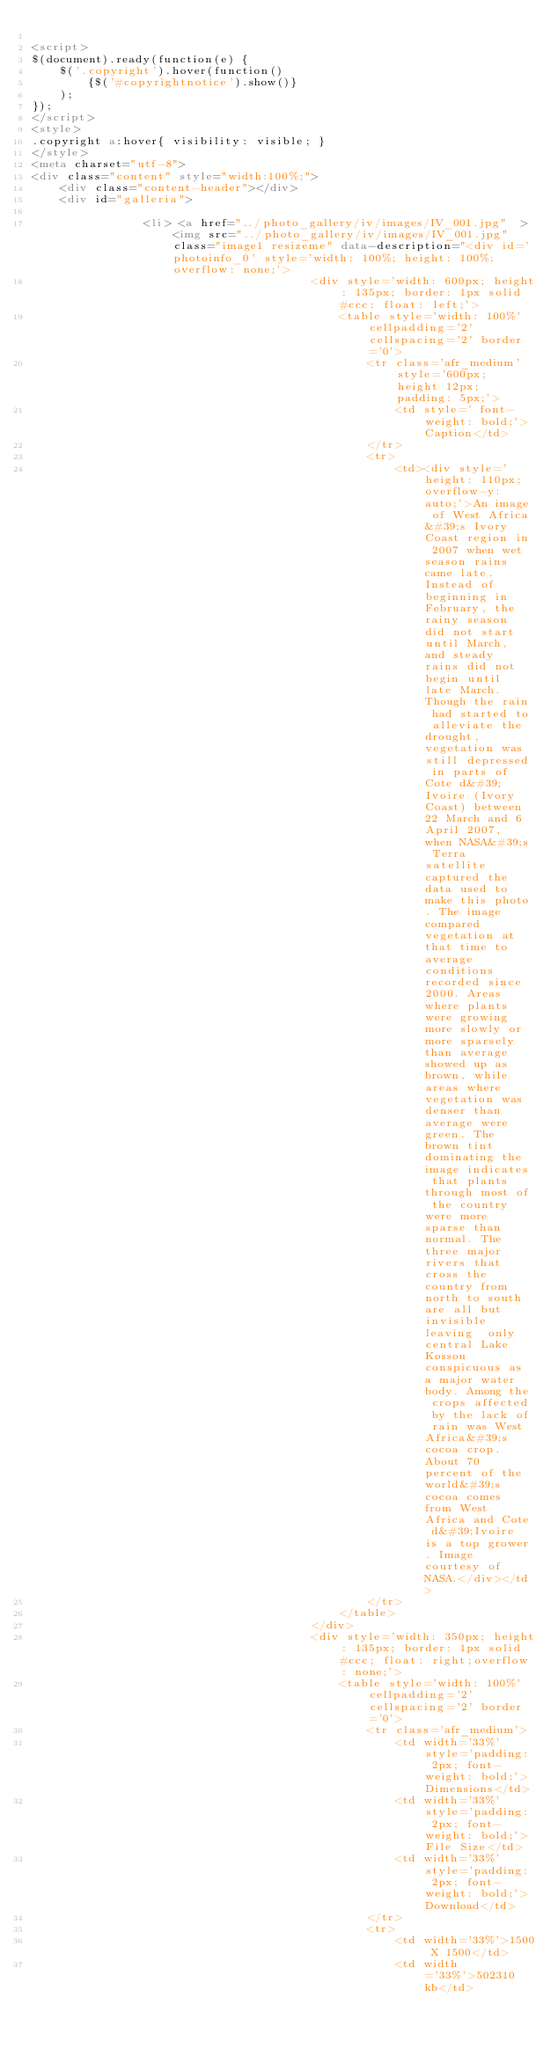Convert code to text. <code><loc_0><loc_0><loc_500><loc_500><_HTML_>
<script>
$(document).ready(function(e) {
	$('.copyright').hover(function() 
		{$('#copyrightnotice').show()}
	);
});
</script>
<style>
.copyright a:hover{ visibility: visible; }
</style>
<meta charset="utf-8">
<div class="content" style="width:100%;">
	<div class="content-header"></div>
	<div id="galleria"> 
		
				<li> <a href="../photo_gallery/iv/images/IV_001.jpg"  > <img src="../photo_gallery/iv/images/IV_001.jpg" class="image1 resizeme" data-description="<div id='photoinfo_0' style='width: 100%; height: 100%; overflow: none;'>
										<div style='width: 600px; height: 135px; border: 1px solid #ccc; float: left;'>
											<table style='width: 100%' cellpadding='2' cellspacing='2' border ='0'>
												<tr class='afr_medium' style='600px; height 12px; padding: 5px;'>
													<td style=' font-weight: bold;'>Caption</td>
												</tr>
												<tr>
													<td><div style='height: 110px; overflow-y: auto;'>An image of West Africa&#39;s Ivory Coast region in 2007 when wet season rains came late. Instead of beginning in February, the rainy season did not start until March, and steady rains did not begin until late March. Though the rain had started to alleviate the drought, vegetation was still depressed in parts of Cote d&#39;Ivoire (Ivory Coast) between 22 March and 6 April 2007, when NASA&#39;s Terra satellite captured the data used to make this photo. The image compared vegetation at that time to average conditions recorded since 2000. Areas where plants were growing more slowly or more sparsely than average showed up as brown, while areas where vegetation was denser than average were green. The brown tint dominating the image indicates that plants through most of the country were more sparse than normal. The three major rivers that cross the country from north to south are all but invisible leaving  only central Lake Kossou conspicuous as a major water body. Among the crops affected by the lack of rain was West Africa&#39;s cocoa crop. About 70 percent of the world&#39;s cocoa comes from West Africa and Cote d&#39;Ivoire is a top grower. Image courtesy of NASA.</div></td>
												</tr>
											</table>
										</div>
										<div style='width: 350px; height: 135px; border: 1px solid #ccc; float: right;overflow: none;'>
											<table style='width: 100%' cellpadding='2' cellspacing='2' border ='0'>
												<tr class='afr_medium'>
													<td width='33%' style='padding: 2px; font-weight: bold;'>Dimensions</td>
													<td width='33%' style='padding: 2px; font-weight: bold;'>File Size</td>
													<td width='33%' style='padding: 2px; font-weight: bold;'>Download</td>
												</tr>
												<tr>
													<td width='33%'>1500 X 1500</td>
													<td width='33%'>502310 kb</td></code> 